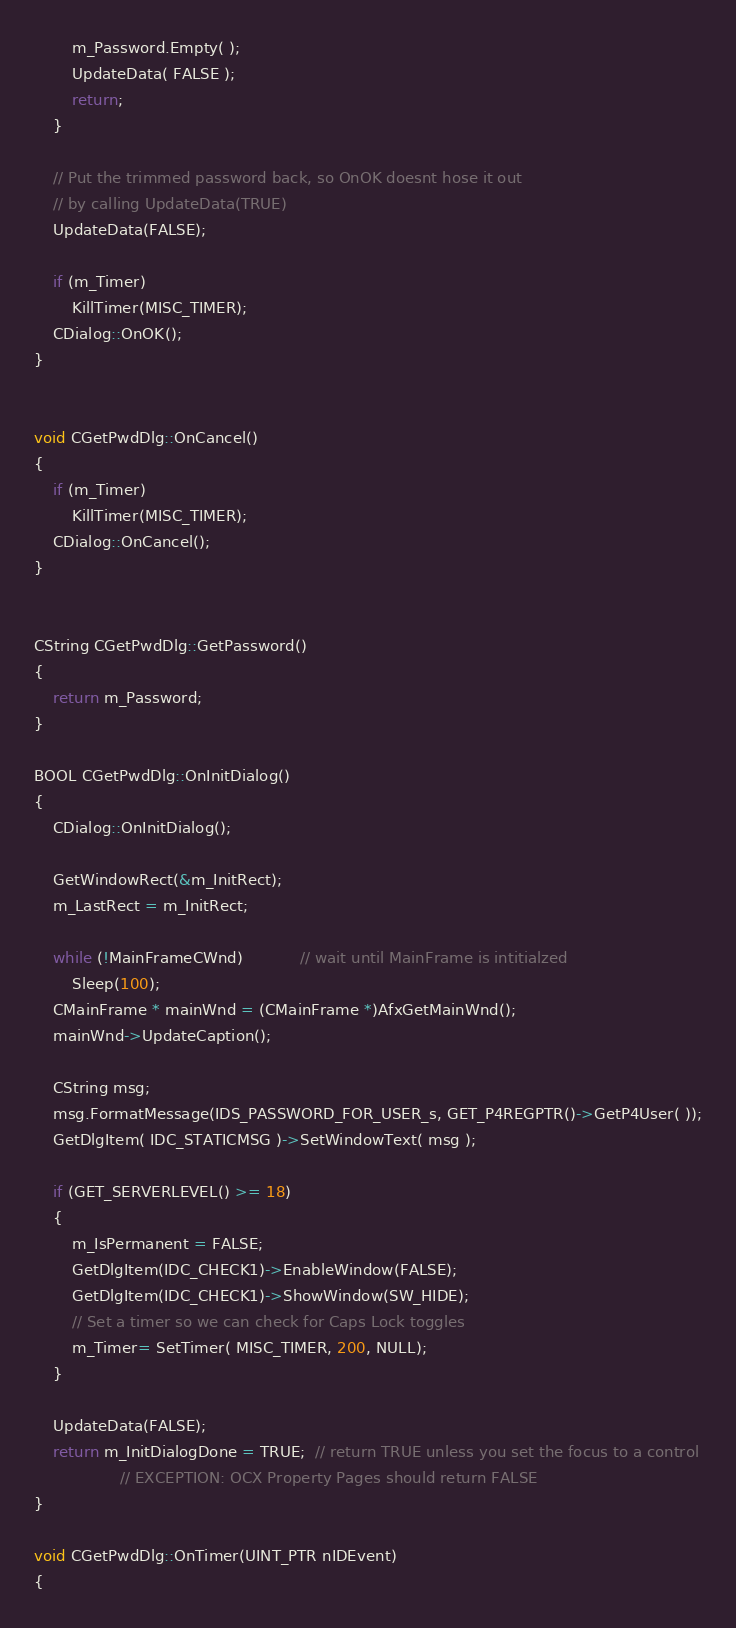<code> <loc_0><loc_0><loc_500><loc_500><_C++_>		m_Password.Empty( );
		UpdateData( FALSE );
		return;
	}

	// Put the trimmed password back, so OnOK doesnt hose it out
	// by calling UpdateData(TRUE)
	UpdateData(FALSE);

	if (m_Timer)
		KillTimer(MISC_TIMER);
	CDialog::OnOK();
}


void CGetPwdDlg::OnCancel() 
{
	if (m_Timer)
		KillTimer(MISC_TIMER);
	CDialog::OnCancel();
}


CString CGetPwdDlg::GetPassword()
{
	return m_Password;
}

BOOL CGetPwdDlg::OnInitDialog() 
{
	CDialog::OnInitDialog();
	
	GetWindowRect(&m_InitRect);
	m_LastRect = m_InitRect;

	while (!MainFrameCWnd)			// wait until MainFrame is intitialzed
		Sleep(100);
	CMainFrame * mainWnd = (CMainFrame *)AfxGetMainWnd();
	mainWnd->UpdateCaption();

	CString msg;
    msg.FormatMessage(IDS_PASSWORD_FOR_USER_s, GET_P4REGPTR()->GetP4User( ));
	GetDlgItem( IDC_STATICMSG )->SetWindowText( msg );

	if (GET_SERVERLEVEL() >= 18)
	{
		m_IsPermanent = FALSE;
		GetDlgItem(IDC_CHECK1)->EnableWindow(FALSE);
		GetDlgItem(IDC_CHECK1)->ShowWindow(SW_HIDE);
		// Set a timer so we can check for Caps Lock toggles
		m_Timer= SetTimer( MISC_TIMER, 200, NULL);
	}
	
	UpdateData(FALSE);
	return m_InitDialogDone = TRUE;  // return TRUE unless you set the focus to a control
	              // EXCEPTION: OCX Property Pages should return FALSE
}

void CGetPwdDlg::OnTimer(UINT_PTR nIDEvent) 
{</code> 